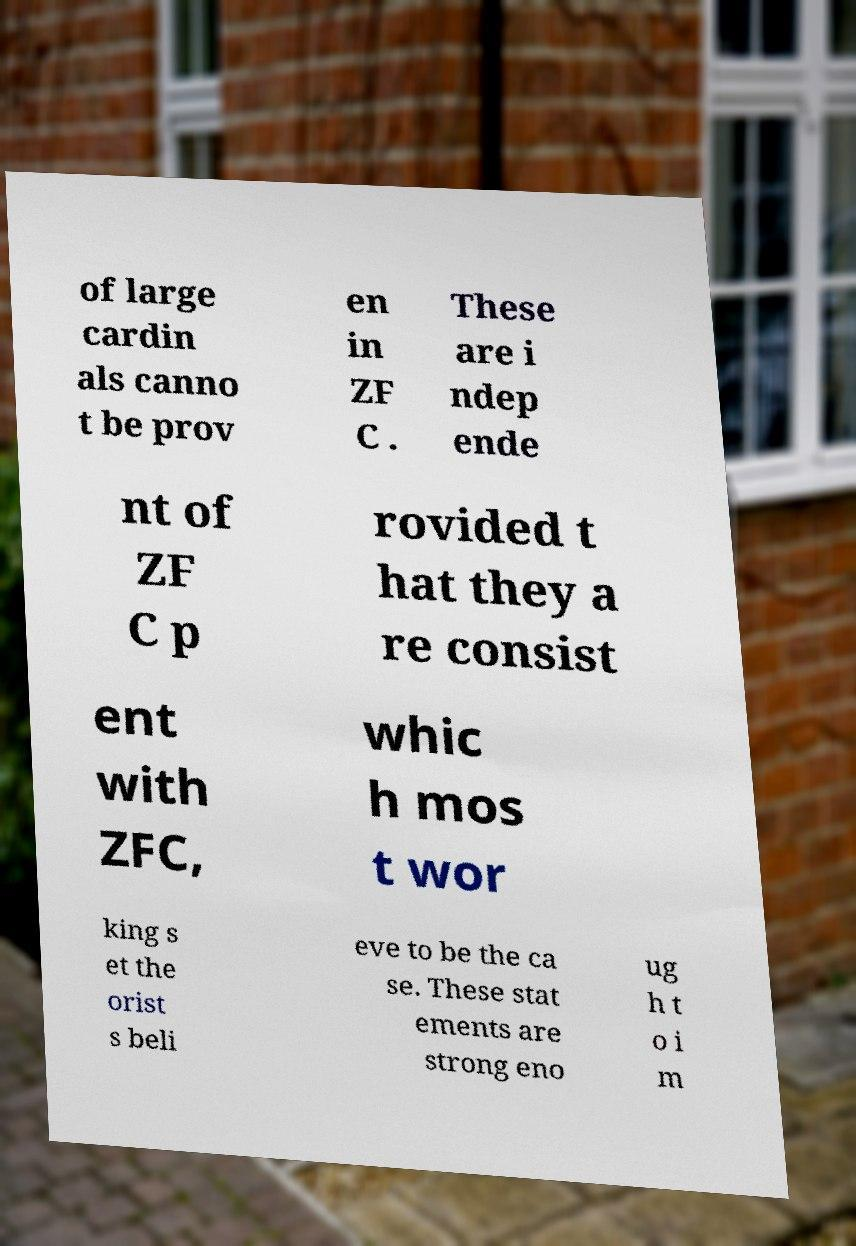Please identify and transcribe the text found in this image. of large cardin als canno t be prov en in ZF C . These are i ndep ende nt of ZF C p rovided t hat they a re consist ent with ZFC, whic h mos t wor king s et the orist s beli eve to be the ca se. These stat ements are strong eno ug h t o i m 